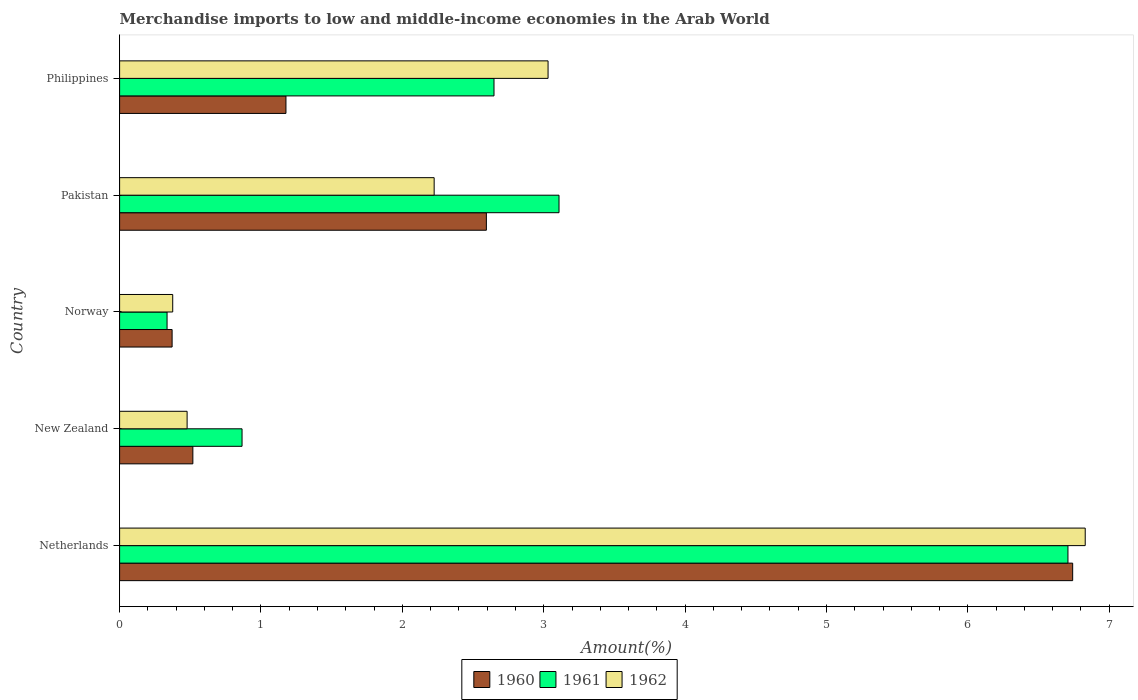Are the number of bars per tick equal to the number of legend labels?
Keep it short and to the point. Yes. Are the number of bars on each tick of the Y-axis equal?
Ensure brevity in your answer.  Yes. What is the label of the 4th group of bars from the top?
Your answer should be compact. New Zealand. What is the percentage of amount earned from merchandise imports in 1960 in Philippines?
Your answer should be very brief. 1.18. Across all countries, what is the maximum percentage of amount earned from merchandise imports in 1962?
Keep it short and to the point. 6.83. Across all countries, what is the minimum percentage of amount earned from merchandise imports in 1962?
Offer a terse response. 0.38. In which country was the percentage of amount earned from merchandise imports in 1961 minimum?
Keep it short and to the point. Norway. What is the total percentage of amount earned from merchandise imports in 1961 in the graph?
Keep it short and to the point. 13.67. What is the difference between the percentage of amount earned from merchandise imports in 1962 in Netherlands and that in Pakistan?
Offer a terse response. 4.61. What is the difference between the percentage of amount earned from merchandise imports in 1960 in New Zealand and the percentage of amount earned from merchandise imports in 1962 in Philippines?
Offer a terse response. -2.51. What is the average percentage of amount earned from merchandise imports in 1962 per country?
Offer a very short reply. 2.59. What is the difference between the percentage of amount earned from merchandise imports in 1960 and percentage of amount earned from merchandise imports in 1961 in Norway?
Your answer should be very brief. 0.04. What is the ratio of the percentage of amount earned from merchandise imports in 1962 in Netherlands to that in New Zealand?
Give a very brief answer. 14.3. Is the percentage of amount earned from merchandise imports in 1961 in Netherlands less than that in New Zealand?
Ensure brevity in your answer.  No. What is the difference between the highest and the second highest percentage of amount earned from merchandise imports in 1961?
Offer a very short reply. 3.6. What is the difference between the highest and the lowest percentage of amount earned from merchandise imports in 1962?
Provide a succinct answer. 6.45. Is the sum of the percentage of amount earned from merchandise imports in 1960 in Norway and Philippines greater than the maximum percentage of amount earned from merchandise imports in 1962 across all countries?
Give a very brief answer. No. What does the 1st bar from the bottom in New Zealand represents?
Offer a terse response. 1960. How many bars are there?
Keep it short and to the point. 15. What is the difference between two consecutive major ticks on the X-axis?
Your answer should be compact. 1. Does the graph contain grids?
Offer a very short reply. No. Where does the legend appear in the graph?
Offer a terse response. Bottom center. What is the title of the graph?
Give a very brief answer. Merchandise imports to low and middle-income economies in the Arab World. Does "1986" appear as one of the legend labels in the graph?
Your answer should be very brief. No. What is the label or title of the X-axis?
Offer a terse response. Amount(%). What is the Amount(%) in 1960 in Netherlands?
Provide a succinct answer. 6.74. What is the Amount(%) of 1961 in Netherlands?
Offer a terse response. 6.71. What is the Amount(%) in 1962 in Netherlands?
Offer a very short reply. 6.83. What is the Amount(%) of 1960 in New Zealand?
Keep it short and to the point. 0.52. What is the Amount(%) of 1961 in New Zealand?
Ensure brevity in your answer.  0.87. What is the Amount(%) in 1962 in New Zealand?
Your response must be concise. 0.48. What is the Amount(%) in 1960 in Norway?
Offer a very short reply. 0.37. What is the Amount(%) of 1961 in Norway?
Offer a very short reply. 0.34. What is the Amount(%) of 1962 in Norway?
Make the answer very short. 0.38. What is the Amount(%) in 1960 in Pakistan?
Ensure brevity in your answer.  2.59. What is the Amount(%) of 1961 in Pakistan?
Give a very brief answer. 3.11. What is the Amount(%) of 1962 in Pakistan?
Your answer should be very brief. 2.22. What is the Amount(%) of 1960 in Philippines?
Give a very brief answer. 1.18. What is the Amount(%) of 1961 in Philippines?
Give a very brief answer. 2.65. What is the Amount(%) of 1962 in Philippines?
Ensure brevity in your answer.  3.03. Across all countries, what is the maximum Amount(%) of 1960?
Your response must be concise. 6.74. Across all countries, what is the maximum Amount(%) of 1961?
Make the answer very short. 6.71. Across all countries, what is the maximum Amount(%) of 1962?
Provide a short and direct response. 6.83. Across all countries, what is the minimum Amount(%) in 1960?
Your answer should be compact. 0.37. Across all countries, what is the minimum Amount(%) of 1961?
Offer a very short reply. 0.34. Across all countries, what is the minimum Amount(%) of 1962?
Make the answer very short. 0.38. What is the total Amount(%) in 1960 in the graph?
Keep it short and to the point. 11.4. What is the total Amount(%) in 1961 in the graph?
Ensure brevity in your answer.  13.67. What is the total Amount(%) in 1962 in the graph?
Your response must be concise. 12.94. What is the difference between the Amount(%) in 1960 in Netherlands and that in New Zealand?
Make the answer very short. 6.22. What is the difference between the Amount(%) in 1961 in Netherlands and that in New Zealand?
Keep it short and to the point. 5.84. What is the difference between the Amount(%) in 1962 in Netherlands and that in New Zealand?
Give a very brief answer. 6.35. What is the difference between the Amount(%) of 1960 in Netherlands and that in Norway?
Provide a succinct answer. 6.37. What is the difference between the Amount(%) in 1961 in Netherlands and that in Norway?
Offer a very short reply. 6.37. What is the difference between the Amount(%) of 1962 in Netherlands and that in Norway?
Provide a short and direct response. 6.45. What is the difference between the Amount(%) of 1960 in Netherlands and that in Pakistan?
Your answer should be compact. 4.15. What is the difference between the Amount(%) in 1961 in Netherlands and that in Pakistan?
Make the answer very short. 3.6. What is the difference between the Amount(%) of 1962 in Netherlands and that in Pakistan?
Give a very brief answer. 4.61. What is the difference between the Amount(%) in 1960 in Netherlands and that in Philippines?
Your answer should be very brief. 5.56. What is the difference between the Amount(%) in 1961 in Netherlands and that in Philippines?
Your answer should be very brief. 4.06. What is the difference between the Amount(%) of 1962 in Netherlands and that in Philippines?
Provide a short and direct response. 3.8. What is the difference between the Amount(%) in 1960 in New Zealand and that in Norway?
Your answer should be compact. 0.15. What is the difference between the Amount(%) in 1961 in New Zealand and that in Norway?
Your response must be concise. 0.53. What is the difference between the Amount(%) of 1962 in New Zealand and that in Norway?
Your response must be concise. 0.1. What is the difference between the Amount(%) in 1960 in New Zealand and that in Pakistan?
Offer a very short reply. -2.08. What is the difference between the Amount(%) of 1961 in New Zealand and that in Pakistan?
Give a very brief answer. -2.24. What is the difference between the Amount(%) of 1962 in New Zealand and that in Pakistan?
Give a very brief answer. -1.75. What is the difference between the Amount(%) in 1960 in New Zealand and that in Philippines?
Your answer should be very brief. -0.66. What is the difference between the Amount(%) of 1961 in New Zealand and that in Philippines?
Offer a terse response. -1.78. What is the difference between the Amount(%) in 1962 in New Zealand and that in Philippines?
Offer a terse response. -2.55. What is the difference between the Amount(%) in 1960 in Norway and that in Pakistan?
Give a very brief answer. -2.22. What is the difference between the Amount(%) in 1961 in Norway and that in Pakistan?
Your answer should be very brief. -2.77. What is the difference between the Amount(%) of 1962 in Norway and that in Pakistan?
Ensure brevity in your answer.  -1.85. What is the difference between the Amount(%) in 1960 in Norway and that in Philippines?
Make the answer very short. -0.81. What is the difference between the Amount(%) of 1961 in Norway and that in Philippines?
Make the answer very short. -2.31. What is the difference between the Amount(%) in 1962 in Norway and that in Philippines?
Your answer should be very brief. -2.66. What is the difference between the Amount(%) of 1960 in Pakistan and that in Philippines?
Offer a very short reply. 1.42. What is the difference between the Amount(%) of 1961 in Pakistan and that in Philippines?
Ensure brevity in your answer.  0.46. What is the difference between the Amount(%) in 1962 in Pakistan and that in Philippines?
Offer a terse response. -0.81. What is the difference between the Amount(%) of 1960 in Netherlands and the Amount(%) of 1961 in New Zealand?
Provide a short and direct response. 5.88. What is the difference between the Amount(%) in 1960 in Netherlands and the Amount(%) in 1962 in New Zealand?
Give a very brief answer. 6.26. What is the difference between the Amount(%) in 1961 in Netherlands and the Amount(%) in 1962 in New Zealand?
Provide a short and direct response. 6.23. What is the difference between the Amount(%) in 1960 in Netherlands and the Amount(%) in 1961 in Norway?
Offer a terse response. 6.41. What is the difference between the Amount(%) of 1960 in Netherlands and the Amount(%) of 1962 in Norway?
Your answer should be compact. 6.37. What is the difference between the Amount(%) of 1961 in Netherlands and the Amount(%) of 1962 in Norway?
Give a very brief answer. 6.33. What is the difference between the Amount(%) of 1960 in Netherlands and the Amount(%) of 1961 in Pakistan?
Offer a terse response. 3.63. What is the difference between the Amount(%) in 1960 in Netherlands and the Amount(%) in 1962 in Pakistan?
Your response must be concise. 4.52. What is the difference between the Amount(%) of 1961 in Netherlands and the Amount(%) of 1962 in Pakistan?
Ensure brevity in your answer.  4.48. What is the difference between the Amount(%) in 1960 in Netherlands and the Amount(%) in 1961 in Philippines?
Provide a short and direct response. 4.09. What is the difference between the Amount(%) in 1960 in Netherlands and the Amount(%) in 1962 in Philippines?
Your answer should be compact. 3.71. What is the difference between the Amount(%) of 1961 in Netherlands and the Amount(%) of 1962 in Philippines?
Your answer should be very brief. 3.68. What is the difference between the Amount(%) in 1960 in New Zealand and the Amount(%) in 1961 in Norway?
Provide a succinct answer. 0.18. What is the difference between the Amount(%) in 1960 in New Zealand and the Amount(%) in 1962 in Norway?
Make the answer very short. 0.14. What is the difference between the Amount(%) in 1961 in New Zealand and the Amount(%) in 1962 in Norway?
Your response must be concise. 0.49. What is the difference between the Amount(%) of 1960 in New Zealand and the Amount(%) of 1961 in Pakistan?
Provide a succinct answer. -2.59. What is the difference between the Amount(%) in 1960 in New Zealand and the Amount(%) in 1962 in Pakistan?
Make the answer very short. -1.71. What is the difference between the Amount(%) in 1961 in New Zealand and the Amount(%) in 1962 in Pakistan?
Your answer should be compact. -1.36. What is the difference between the Amount(%) of 1960 in New Zealand and the Amount(%) of 1961 in Philippines?
Your response must be concise. -2.13. What is the difference between the Amount(%) in 1960 in New Zealand and the Amount(%) in 1962 in Philippines?
Your response must be concise. -2.51. What is the difference between the Amount(%) of 1961 in New Zealand and the Amount(%) of 1962 in Philippines?
Offer a very short reply. -2.16. What is the difference between the Amount(%) in 1960 in Norway and the Amount(%) in 1961 in Pakistan?
Your answer should be very brief. -2.74. What is the difference between the Amount(%) in 1960 in Norway and the Amount(%) in 1962 in Pakistan?
Give a very brief answer. -1.85. What is the difference between the Amount(%) of 1961 in Norway and the Amount(%) of 1962 in Pakistan?
Give a very brief answer. -1.89. What is the difference between the Amount(%) in 1960 in Norway and the Amount(%) in 1961 in Philippines?
Provide a short and direct response. -2.28. What is the difference between the Amount(%) in 1960 in Norway and the Amount(%) in 1962 in Philippines?
Your answer should be compact. -2.66. What is the difference between the Amount(%) in 1961 in Norway and the Amount(%) in 1962 in Philippines?
Offer a terse response. -2.7. What is the difference between the Amount(%) in 1960 in Pakistan and the Amount(%) in 1961 in Philippines?
Provide a succinct answer. -0.05. What is the difference between the Amount(%) in 1960 in Pakistan and the Amount(%) in 1962 in Philippines?
Make the answer very short. -0.44. What is the difference between the Amount(%) of 1961 in Pakistan and the Amount(%) of 1962 in Philippines?
Make the answer very short. 0.08. What is the average Amount(%) of 1960 per country?
Provide a short and direct response. 2.28. What is the average Amount(%) in 1961 per country?
Your answer should be compact. 2.73. What is the average Amount(%) of 1962 per country?
Your response must be concise. 2.59. What is the difference between the Amount(%) in 1960 and Amount(%) in 1961 in Netherlands?
Give a very brief answer. 0.03. What is the difference between the Amount(%) in 1960 and Amount(%) in 1962 in Netherlands?
Your response must be concise. -0.09. What is the difference between the Amount(%) in 1961 and Amount(%) in 1962 in Netherlands?
Your answer should be compact. -0.12. What is the difference between the Amount(%) of 1960 and Amount(%) of 1961 in New Zealand?
Your answer should be compact. -0.35. What is the difference between the Amount(%) of 1960 and Amount(%) of 1962 in New Zealand?
Your answer should be very brief. 0.04. What is the difference between the Amount(%) of 1961 and Amount(%) of 1962 in New Zealand?
Your answer should be compact. 0.39. What is the difference between the Amount(%) of 1960 and Amount(%) of 1961 in Norway?
Give a very brief answer. 0.04. What is the difference between the Amount(%) in 1960 and Amount(%) in 1962 in Norway?
Your answer should be compact. -0. What is the difference between the Amount(%) in 1961 and Amount(%) in 1962 in Norway?
Provide a short and direct response. -0.04. What is the difference between the Amount(%) in 1960 and Amount(%) in 1961 in Pakistan?
Your answer should be very brief. -0.51. What is the difference between the Amount(%) of 1960 and Amount(%) of 1962 in Pakistan?
Give a very brief answer. 0.37. What is the difference between the Amount(%) in 1961 and Amount(%) in 1962 in Pakistan?
Offer a terse response. 0.88. What is the difference between the Amount(%) of 1960 and Amount(%) of 1961 in Philippines?
Your answer should be very brief. -1.47. What is the difference between the Amount(%) in 1960 and Amount(%) in 1962 in Philippines?
Ensure brevity in your answer.  -1.85. What is the difference between the Amount(%) in 1961 and Amount(%) in 1962 in Philippines?
Make the answer very short. -0.38. What is the ratio of the Amount(%) of 1960 in Netherlands to that in New Zealand?
Ensure brevity in your answer.  13.01. What is the ratio of the Amount(%) of 1961 in Netherlands to that in New Zealand?
Keep it short and to the point. 7.75. What is the ratio of the Amount(%) in 1962 in Netherlands to that in New Zealand?
Offer a very short reply. 14.3. What is the ratio of the Amount(%) of 1960 in Netherlands to that in Norway?
Your answer should be very brief. 18.15. What is the ratio of the Amount(%) in 1961 in Netherlands to that in Norway?
Keep it short and to the point. 19.98. What is the ratio of the Amount(%) of 1962 in Netherlands to that in Norway?
Your answer should be compact. 18.18. What is the ratio of the Amount(%) in 1960 in Netherlands to that in Pakistan?
Your answer should be compact. 2.6. What is the ratio of the Amount(%) in 1961 in Netherlands to that in Pakistan?
Your response must be concise. 2.16. What is the ratio of the Amount(%) in 1962 in Netherlands to that in Pakistan?
Ensure brevity in your answer.  3.07. What is the ratio of the Amount(%) of 1960 in Netherlands to that in Philippines?
Keep it short and to the point. 5.73. What is the ratio of the Amount(%) in 1961 in Netherlands to that in Philippines?
Offer a terse response. 2.53. What is the ratio of the Amount(%) of 1962 in Netherlands to that in Philippines?
Keep it short and to the point. 2.25. What is the ratio of the Amount(%) of 1960 in New Zealand to that in Norway?
Provide a succinct answer. 1.4. What is the ratio of the Amount(%) of 1961 in New Zealand to that in Norway?
Offer a very short reply. 2.58. What is the ratio of the Amount(%) in 1962 in New Zealand to that in Norway?
Your answer should be very brief. 1.27. What is the ratio of the Amount(%) of 1960 in New Zealand to that in Pakistan?
Your response must be concise. 0.2. What is the ratio of the Amount(%) of 1961 in New Zealand to that in Pakistan?
Your answer should be compact. 0.28. What is the ratio of the Amount(%) in 1962 in New Zealand to that in Pakistan?
Offer a very short reply. 0.21. What is the ratio of the Amount(%) of 1960 in New Zealand to that in Philippines?
Offer a very short reply. 0.44. What is the ratio of the Amount(%) in 1961 in New Zealand to that in Philippines?
Keep it short and to the point. 0.33. What is the ratio of the Amount(%) of 1962 in New Zealand to that in Philippines?
Give a very brief answer. 0.16. What is the ratio of the Amount(%) in 1960 in Norway to that in Pakistan?
Give a very brief answer. 0.14. What is the ratio of the Amount(%) of 1961 in Norway to that in Pakistan?
Ensure brevity in your answer.  0.11. What is the ratio of the Amount(%) in 1962 in Norway to that in Pakistan?
Give a very brief answer. 0.17. What is the ratio of the Amount(%) of 1960 in Norway to that in Philippines?
Ensure brevity in your answer.  0.32. What is the ratio of the Amount(%) of 1961 in Norway to that in Philippines?
Make the answer very short. 0.13. What is the ratio of the Amount(%) in 1962 in Norway to that in Philippines?
Offer a terse response. 0.12. What is the ratio of the Amount(%) of 1960 in Pakistan to that in Philippines?
Offer a very short reply. 2.2. What is the ratio of the Amount(%) in 1961 in Pakistan to that in Philippines?
Keep it short and to the point. 1.17. What is the ratio of the Amount(%) of 1962 in Pakistan to that in Philippines?
Make the answer very short. 0.73. What is the difference between the highest and the second highest Amount(%) in 1960?
Make the answer very short. 4.15. What is the difference between the highest and the second highest Amount(%) of 1961?
Your answer should be compact. 3.6. What is the difference between the highest and the second highest Amount(%) of 1962?
Your answer should be compact. 3.8. What is the difference between the highest and the lowest Amount(%) of 1960?
Your answer should be compact. 6.37. What is the difference between the highest and the lowest Amount(%) in 1961?
Your answer should be compact. 6.37. What is the difference between the highest and the lowest Amount(%) of 1962?
Make the answer very short. 6.45. 